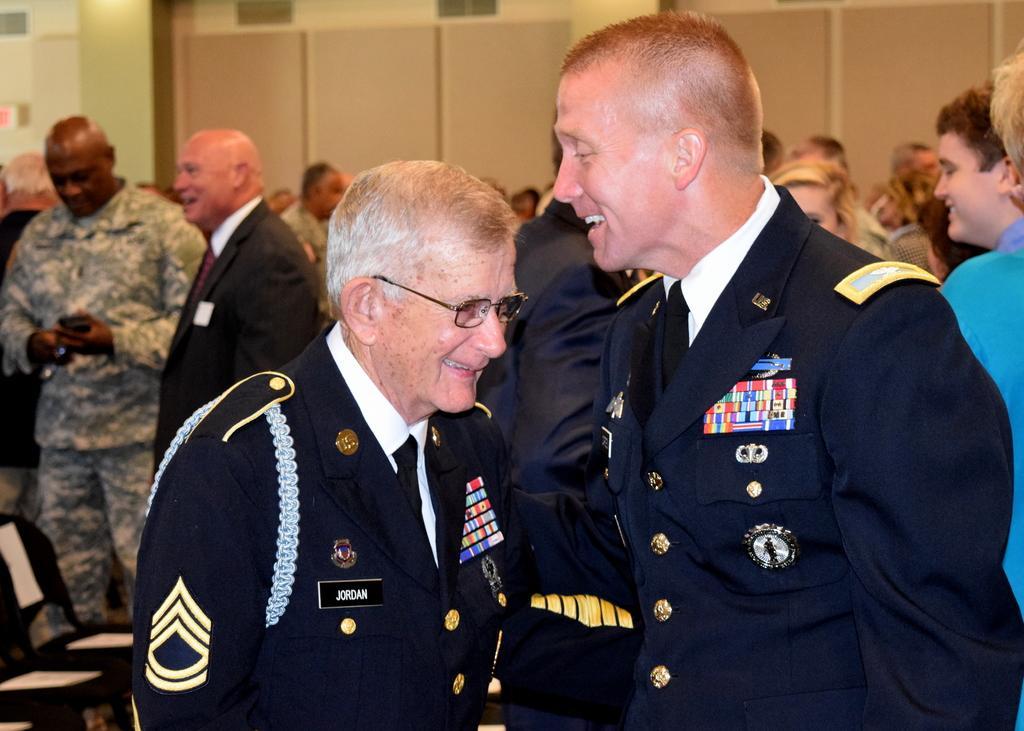Please provide a concise description of this image. In the picture we can see two men are standing face to face and smiling and they are wearing a uniform and in the background also we can see many people are standing and talking to each other, in the background we can see a wall. 